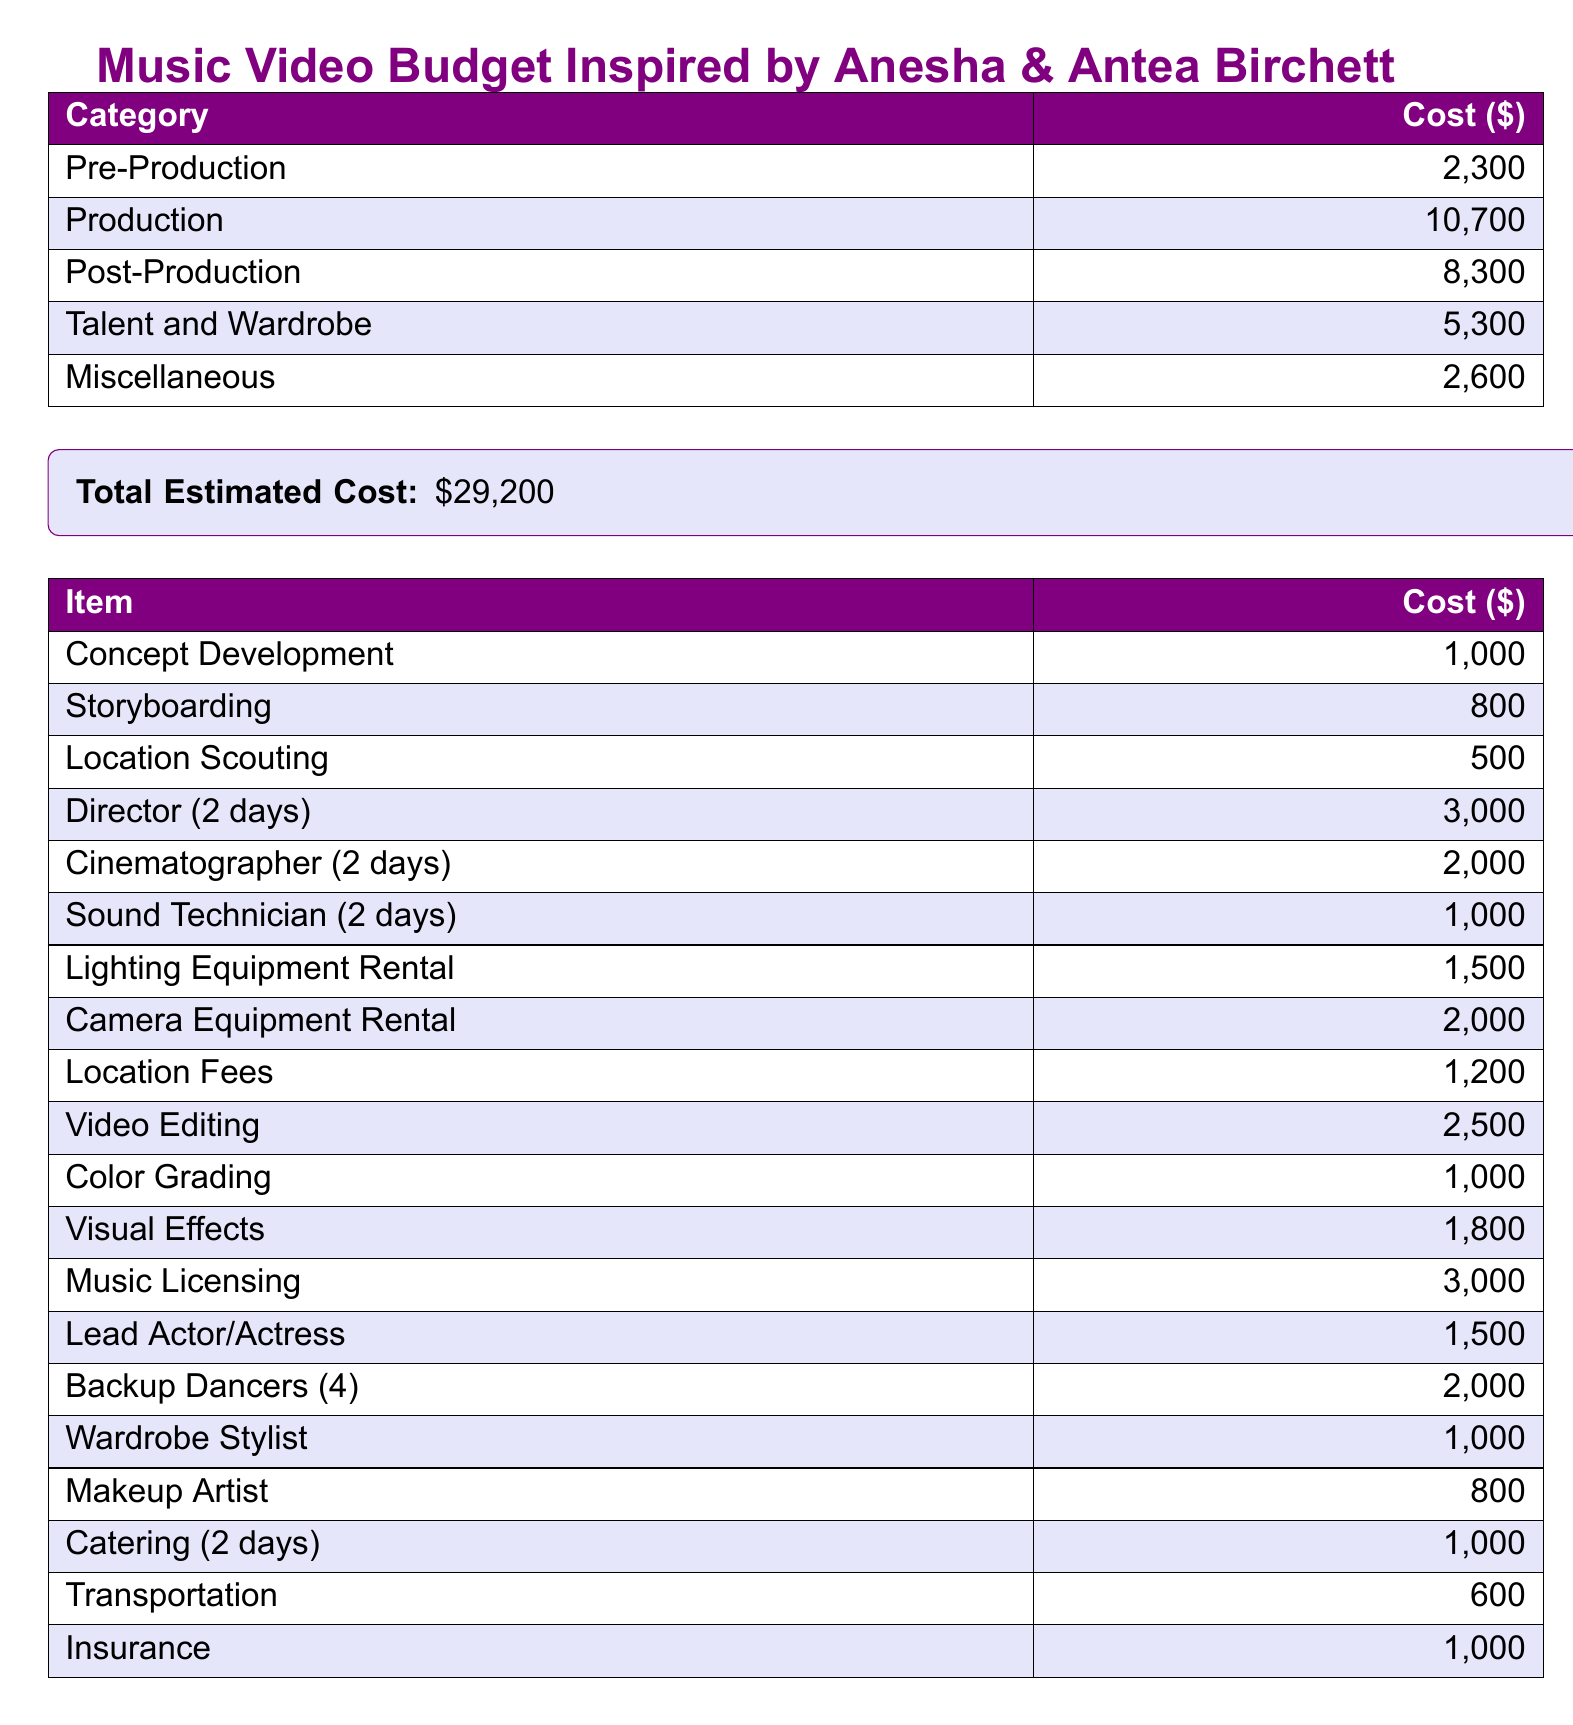What is the total estimated cost? The total estimated cost is presented in the document as a summary of all categories combined, which is $29,200.
Answer: $29,200 How much is allocated for production? The budget document specifies the allocation for production costs, which is explicitly stated as $10,700.
Answer: $10,700 What is the cost for talent and wardrobe? The document provides the amount allocated for talent and wardrobe, which is indicated as $5,300.
Answer: $5,300 How much does location scouting cost? The cost associated with location scouting is listed separately in the detailed breakdown of costs as $500.
Answer: $500 What is the budget for music licensing? The cost for music licensing is mentioned in the document and totals $3,000.
Answer: $3,000 How many backup dancers are included in the budget? The budget mentions four backup dancers, providing a specific detail regarding talent.
Answer: 4 What is the total cost for post-production? The total cost for post-production is explicitly stated as $8,300 in the budget breakdown section.
Answer: $8,300 How much is spent on visual effects? The document specifies the cost for visual effects as $1,800, found within the itemized costs.
Answer: $1,800 What is the cost of a director for two days? The document lists the cost of hiring a director for two days, which is $3,000.
Answer: $3,000 